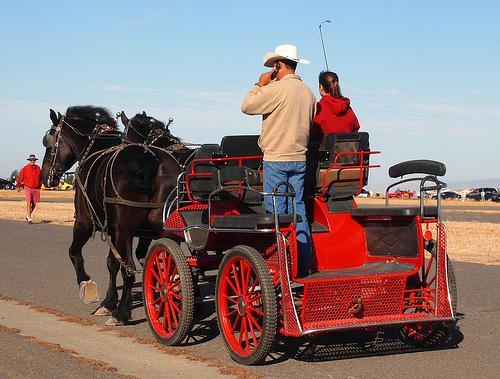Question: what is red?
Choices:
A. A carriage.
B. Cart.
C. Sign.
D. Jacket.
Answer with the letter. Answer: A Question: what is gray?
Choices:
A. The road.
B. Street.
C. The ground.
D. Floor.
Answer with the letter. Answer: A Question: what is blue?
Choices:
A. Water.
B. Shirt.
C. Jacket.
D. Sky.
Answer with the letter. Answer: D Question: who is riding a carriage?
Choices:
A. Man.
B. Woman.
C. Two people.
D. People.
Answer with the letter. Answer: C Question: how many people are in the picture?
Choices:
A. Three.
B. Seven.
C. Zero.
D. Two.
Answer with the letter. Answer: A Question: how many horses are pulling the carriage?
Choices:
A. Six.
B. One.
C. Two.
D. Four.
Answer with the letter. Answer: C Question: what is dark brown?
Choices:
A. Horses.
B. Cows.
C. Donkey.
D. Lambs.
Answer with the letter. Answer: A Question: when was the photo taken?
Choices:
A. Early.
B. Noon.
C. Daytime.
D. 12pm.
Answer with the letter. Answer: C 